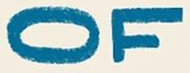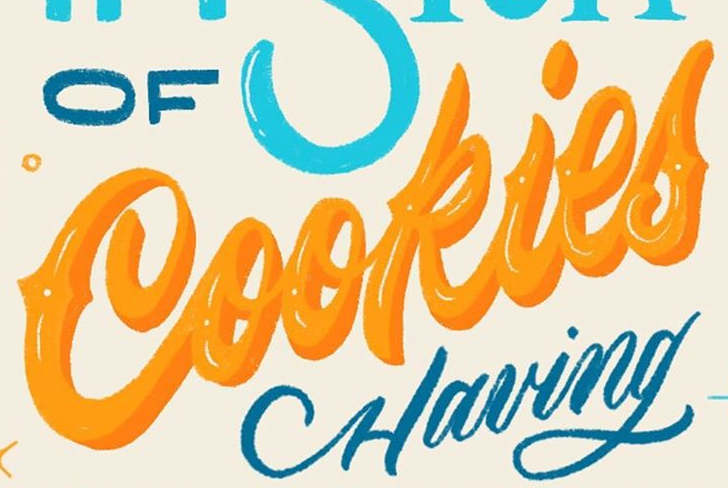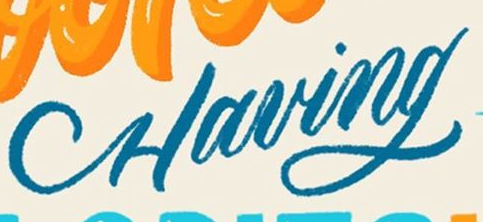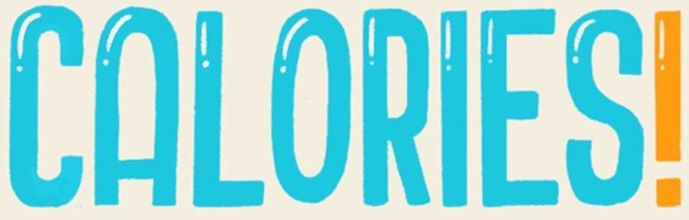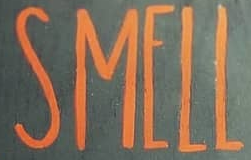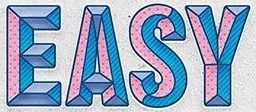Read the text content from these images in order, separated by a semicolon. OF; Cookies; Having; CALORIES!; SMELL; EASY 